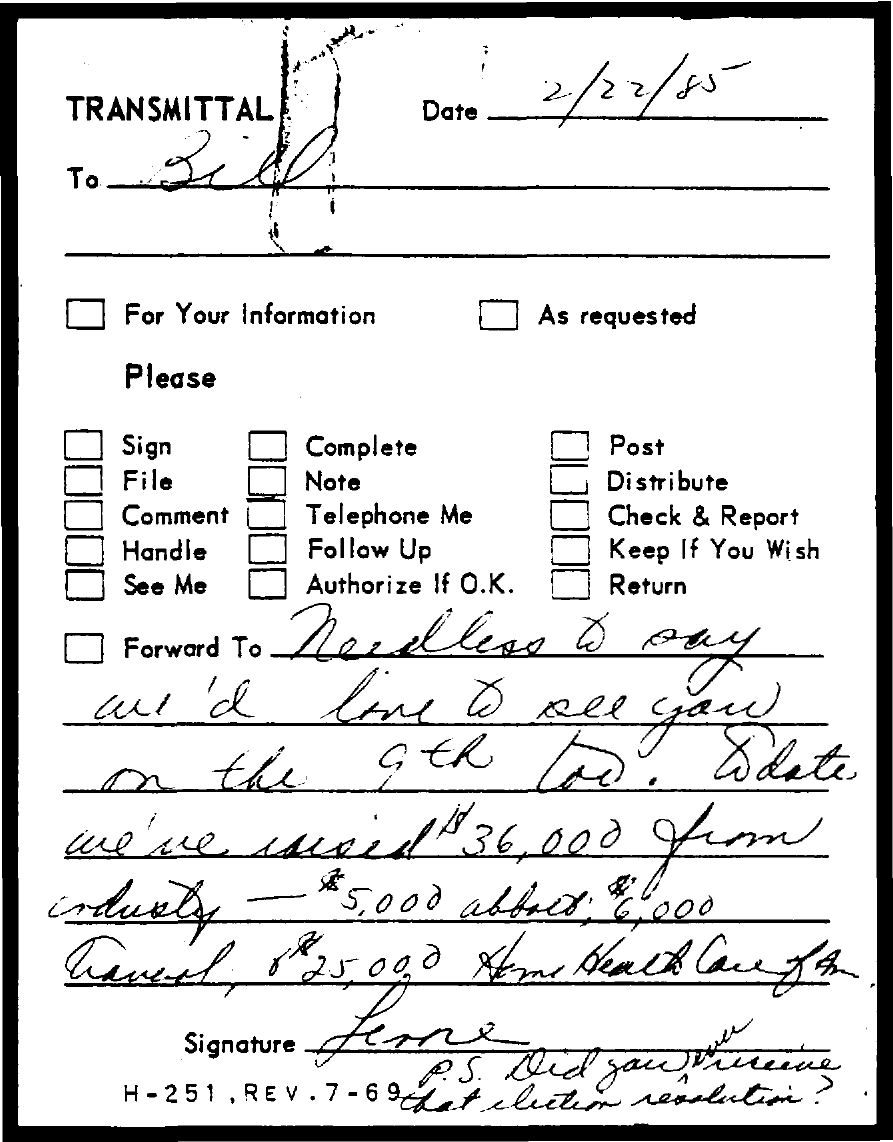Mention a couple of crucial points in this snapshot. The date mentioned in the transmittal is February 22, 1985. The transmittal is addressed to Bill. 